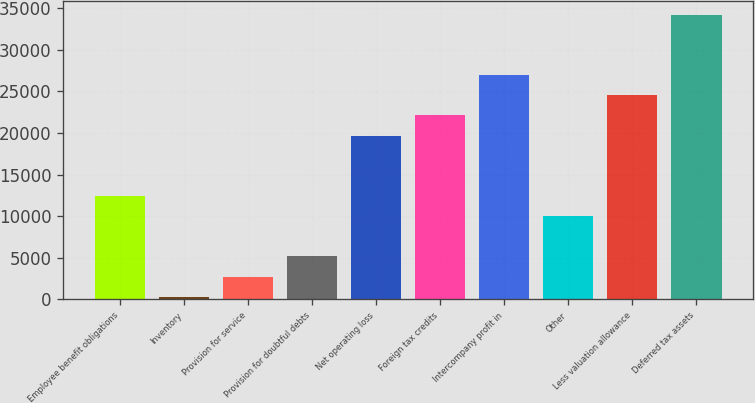Convert chart to OTSL. <chart><loc_0><loc_0><loc_500><loc_500><bar_chart><fcel>Employee benefit obligations<fcel>Inventory<fcel>Provision for service<fcel>Provision for doubtful debts<fcel>Net operating loss<fcel>Foreign tax credits<fcel>Intercompany profit in<fcel>Other<fcel>Less valuation allowance<fcel>Deferred tax assets<nl><fcel>12416.5<fcel>301<fcel>2724.1<fcel>5147.2<fcel>19685.8<fcel>22108.9<fcel>26955.1<fcel>9993.4<fcel>24532<fcel>34224.4<nl></chart> 